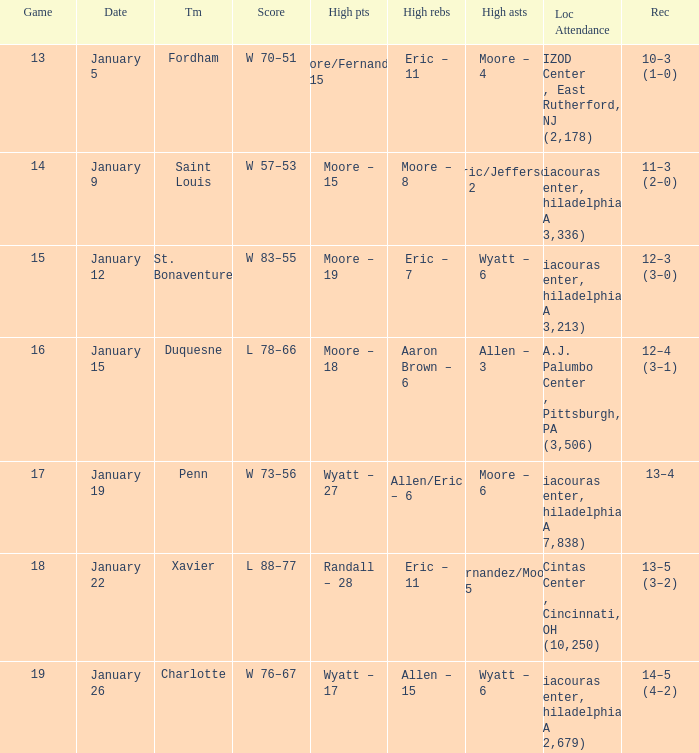What team was Temple playing on January 19? Penn. 